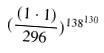<formula> <loc_0><loc_0><loc_500><loc_500>( \frac { ( 1 \cdot 1 ) } { 2 9 6 } ) ^ { 1 3 8 ^ { 1 3 0 } }</formula> 